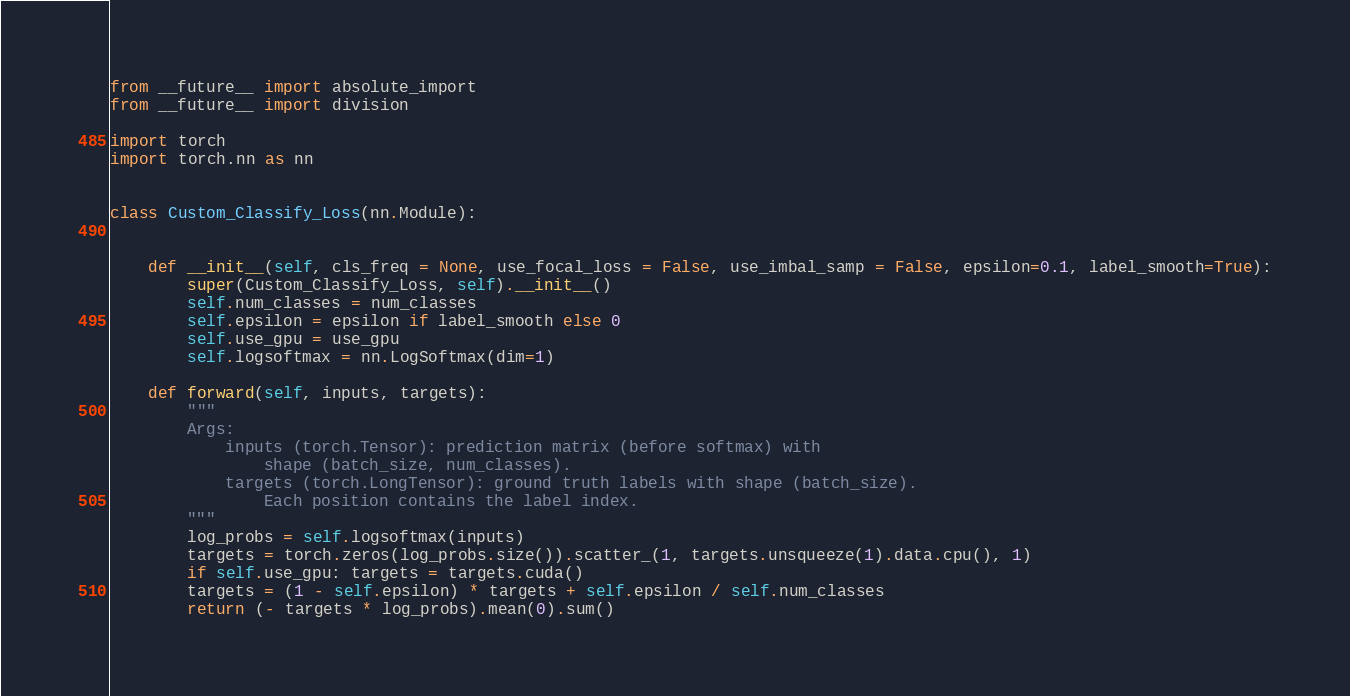Convert code to text. <code><loc_0><loc_0><loc_500><loc_500><_Python_>from __future__ import absolute_import
from __future__ import division

import torch
import torch.nn as nn


class Custom_Classify_Loss(nn.Module):

    
    def __init__(self, cls_freq = None, use_focal_loss = False, use_imbal_samp = False, epsilon=0.1, label_smooth=True):
        super(Custom_Classify_Loss, self).__init__()
        self.num_classes = num_classes
        self.epsilon = epsilon if label_smooth else 0
        self.use_gpu = use_gpu
        self.logsoftmax = nn.LogSoftmax(dim=1)

    def forward(self, inputs, targets):
        """
        Args:
            inputs (torch.Tensor): prediction matrix (before softmax) with
                shape (batch_size, num_classes).
            targets (torch.LongTensor): ground truth labels with shape (batch_size).
                Each position contains the label index.
        """
        log_probs = self.logsoftmax(inputs)
        targets = torch.zeros(log_probs.size()).scatter_(1, targets.unsqueeze(1).data.cpu(), 1)
        if self.use_gpu: targets = targets.cuda()
        targets = (1 - self.epsilon) * targets + self.epsilon / self.num_classes
        return (- targets * log_probs).mean(0).sum()
</code> 